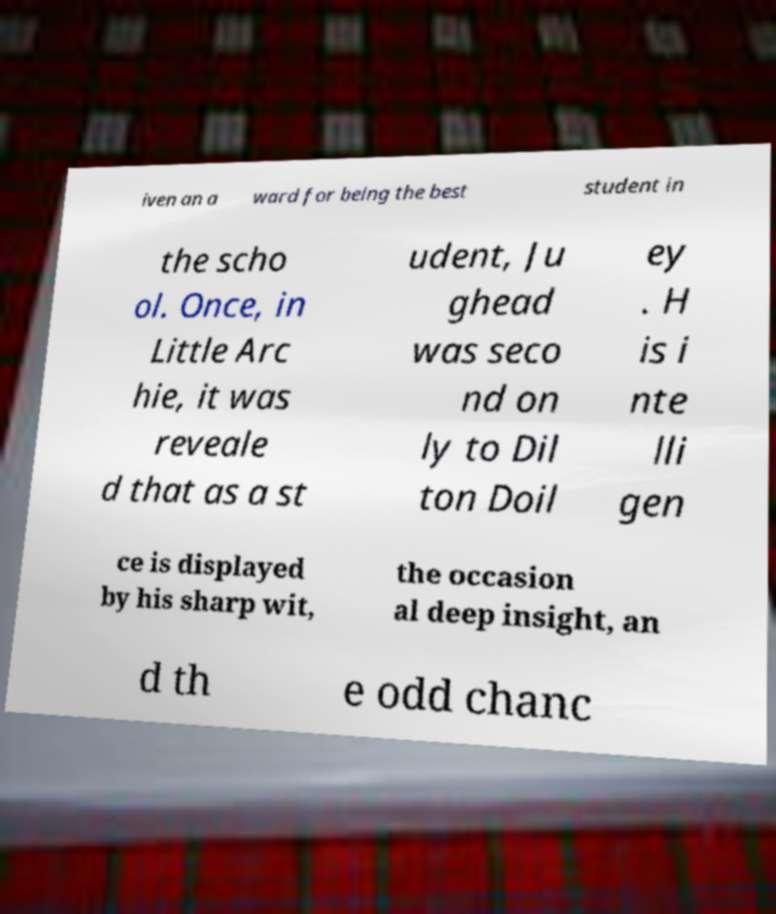For documentation purposes, I need the text within this image transcribed. Could you provide that? iven an a ward for being the best student in the scho ol. Once, in Little Arc hie, it was reveale d that as a st udent, Ju ghead was seco nd on ly to Dil ton Doil ey . H is i nte lli gen ce is displayed by his sharp wit, the occasion al deep insight, an d th e odd chanc 